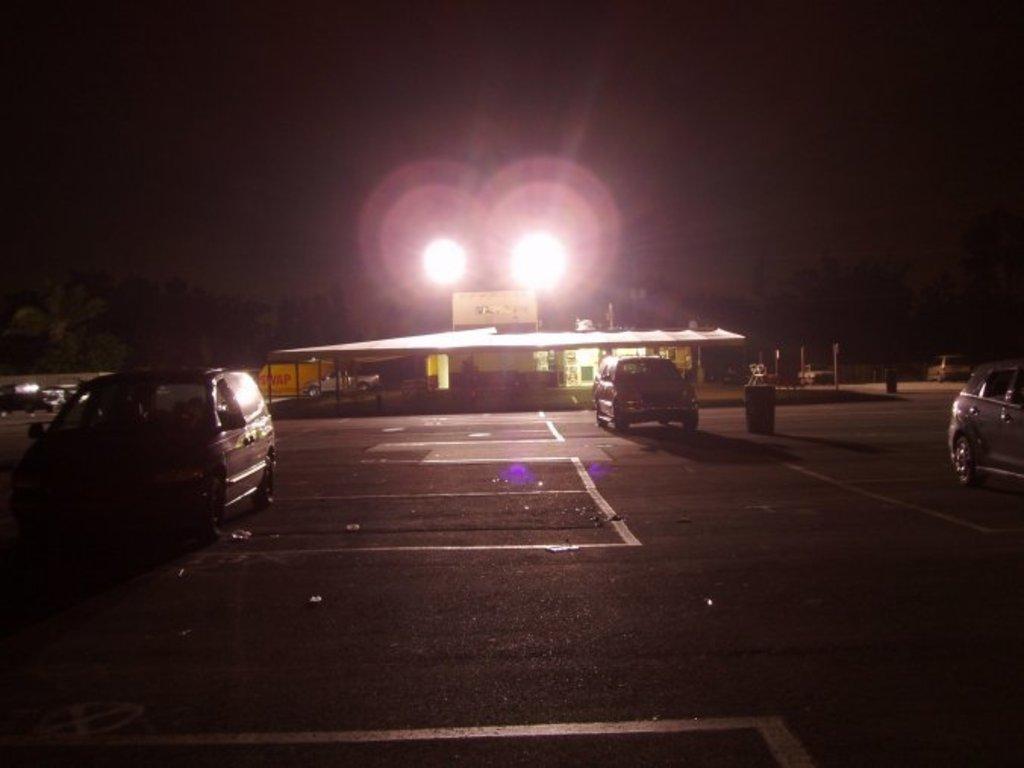Could you give a brief overview of what you see in this image? In this image I can see some vehicles on the road. In the background, I can see the lights. 